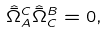<formula> <loc_0><loc_0><loc_500><loc_500>\hat { \bar { \Omega } } _ { A } ^ { C } \hat { \bar { \Omega } } _ { C } ^ { B } = 0 ,</formula> 